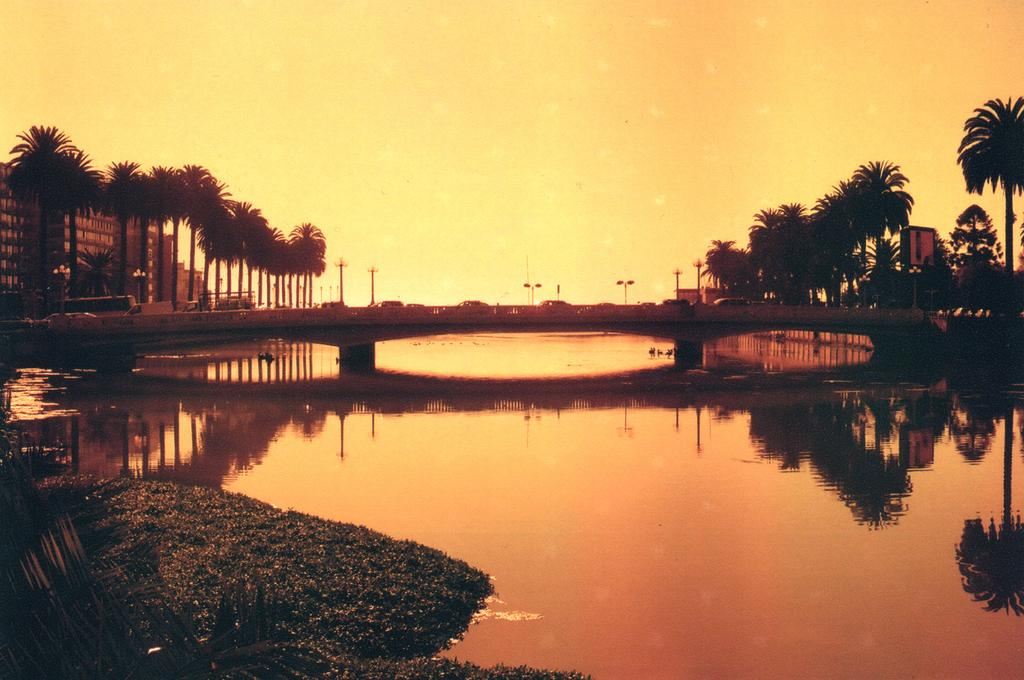What is the primary element visible in the image? There is water in the image. What type of natural vegetation can be seen in the image? There are trees in the image. What structure is present in the water? There is a bridge in the image. What is happening on the bridge? Vehicles are present on the bridge. What can be seen in the background of the image? There are buildings, trees, electric poles, and the sky visible in the background of the image. What type of humor can be seen in the image? There is no humor present in the image; it is a scene of a bridge, water, and surrounding elements. How many eggs are visible in the image? There are no eggs present in the image. 